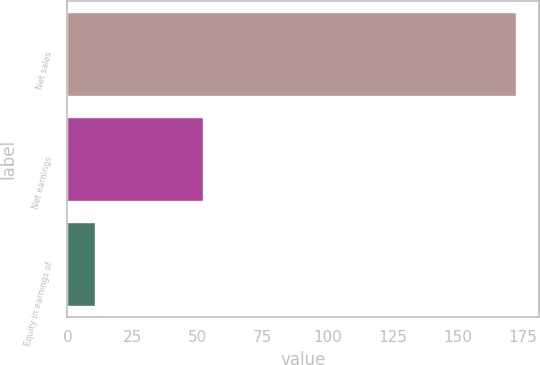Convert chart to OTSL. <chart><loc_0><loc_0><loc_500><loc_500><bar_chart><fcel>Net sales<fcel>Net earnings<fcel>Equity in earnings of<nl><fcel>172.6<fcel>52.3<fcel>10.6<nl></chart> 